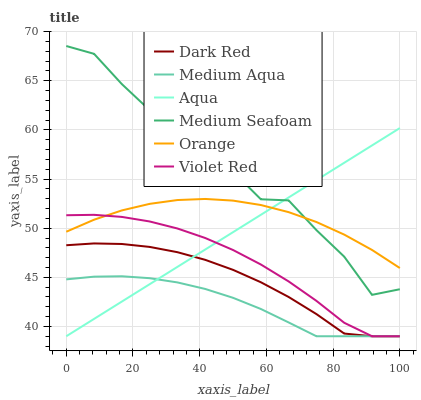Does Medium Aqua have the minimum area under the curve?
Answer yes or no. Yes. Does Medium Seafoam have the maximum area under the curve?
Answer yes or no. Yes. Does Dark Red have the minimum area under the curve?
Answer yes or no. No. Does Dark Red have the maximum area under the curve?
Answer yes or no. No. Is Aqua the smoothest?
Answer yes or no. Yes. Is Medium Seafoam the roughest?
Answer yes or no. Yes. Is Dark Red the smoothest?
Answer yes or no. No. Is Dark Red the roughest?
Answer yes or no. No. Does Violet Red have the lowest value?
Answer yes or no. Yes. Does Orange have the lowest value?
Answer yes or no. No. Does Medium Seafoam have the highest value?
Answer yes or no. Yes. Does Dark Red have the highest value?
Answer yes or no. No. Is Dark Red less than Medium Seafoam?
Answer yes or no. Yes. Is Medium Seafoam greater than Dark Red?
Answer yes or no. Yes. Does Aqua intersect Dark Red?
Answer yes or no. Yes. Is Aqua less than Dark Red?
Answer yes or no. No. Is Aqua greater than Dark Red?
Answer yes or no. No. Does Dark Red intersect Medium Seafoam?
Answer yes or no. No. 